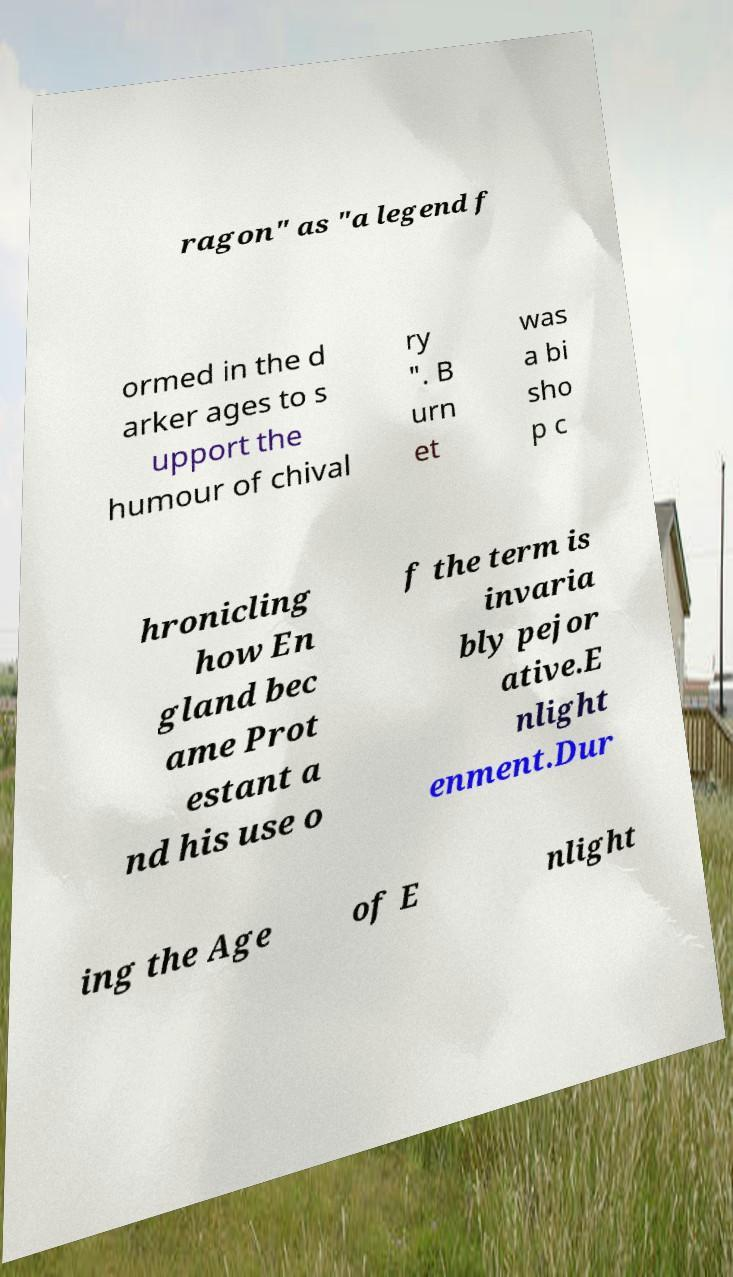I need the written content from this picture converted into text. Can you do that? ragon" as "a legend f ormed in the d arker ages to s upport the humour of chival ry ". B urn et was a bi sho p c hronicling how En gland bec ame Prot estant a nd his use o f the term is invaria bly pejor ative.E nlight enment.Dur ing the Age of E nlight 